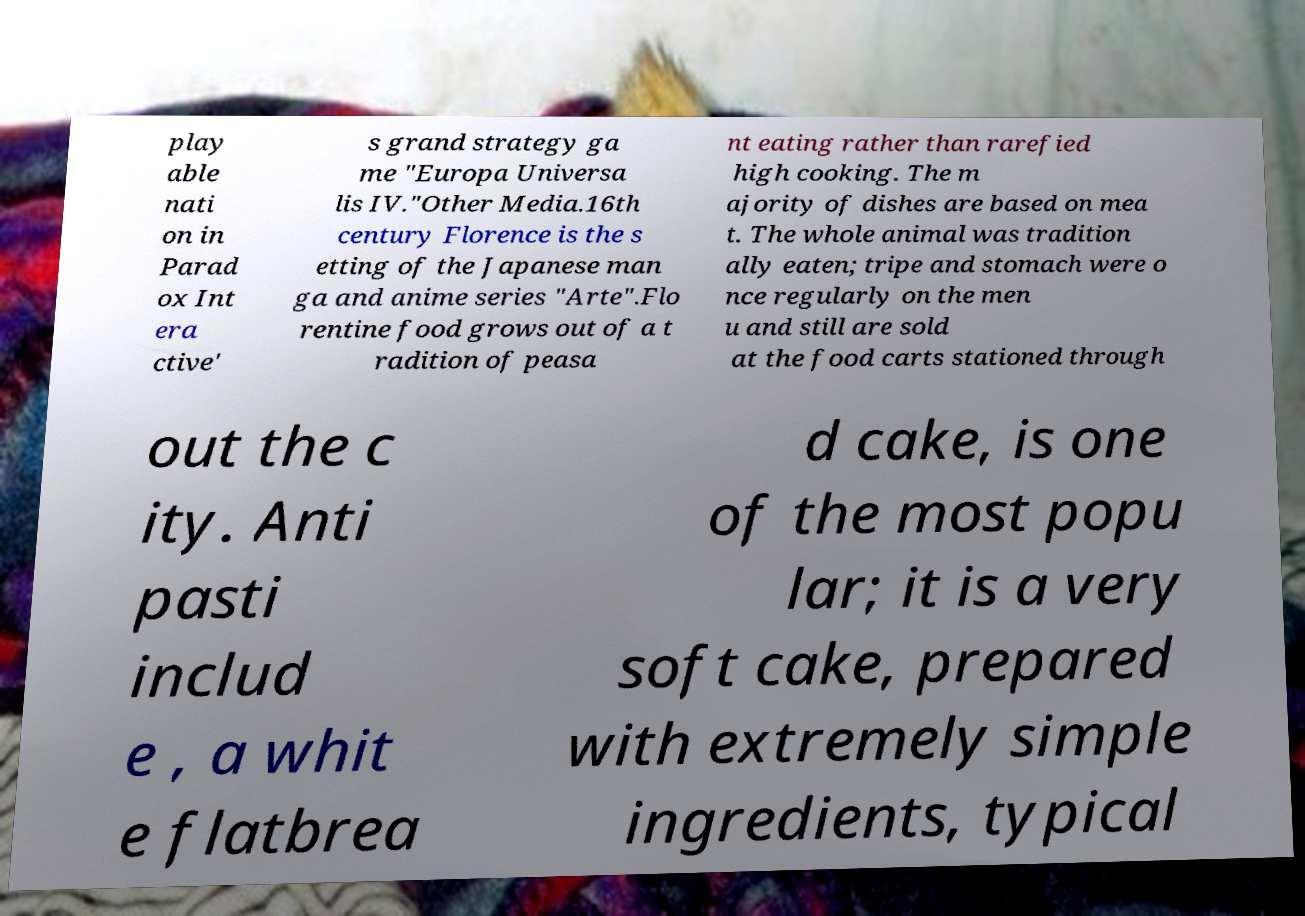Could you assist in decoding the text presented in this image and type it out clearly? play able nati on in Parad ox Int era ctive' s grand strategy ga me "Europa Universa lis IV."Other Media.16th century Florence is the s etting of the Japanese man ga and anime series "Arte".Flo rentine food grows out of a t radition of peasa nt eating rather than rarefied high cooking. The m ajority of dishes are based on mea t. The whole animal was tradition ally eaten; tripe and stomach were o nce regularly on the men u and still are sold at the food carts stationed through out the c ity. Anti pasti includ e , a whit e flatbrea d cake, is one of the most popu lar; it is a very soft cake, prepared with extremely simple ingredients, typical 